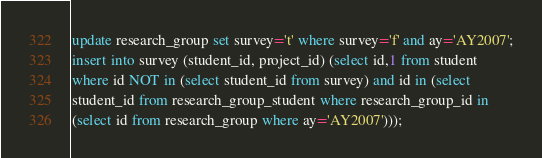Convert code to text. <code><loc_0><loc_0><loc_500><loc_500><_SQL_>update research_group set survey='t' where survey='f' and ay='AY2007';
insert into survey (student_id, project_id) (select id,1 from student
where id NOT in (select student_id from survey) and id in (select
student_id from research_group_student where research_group_id in
(select id from research_group where ay='AY2007')));
</code> 